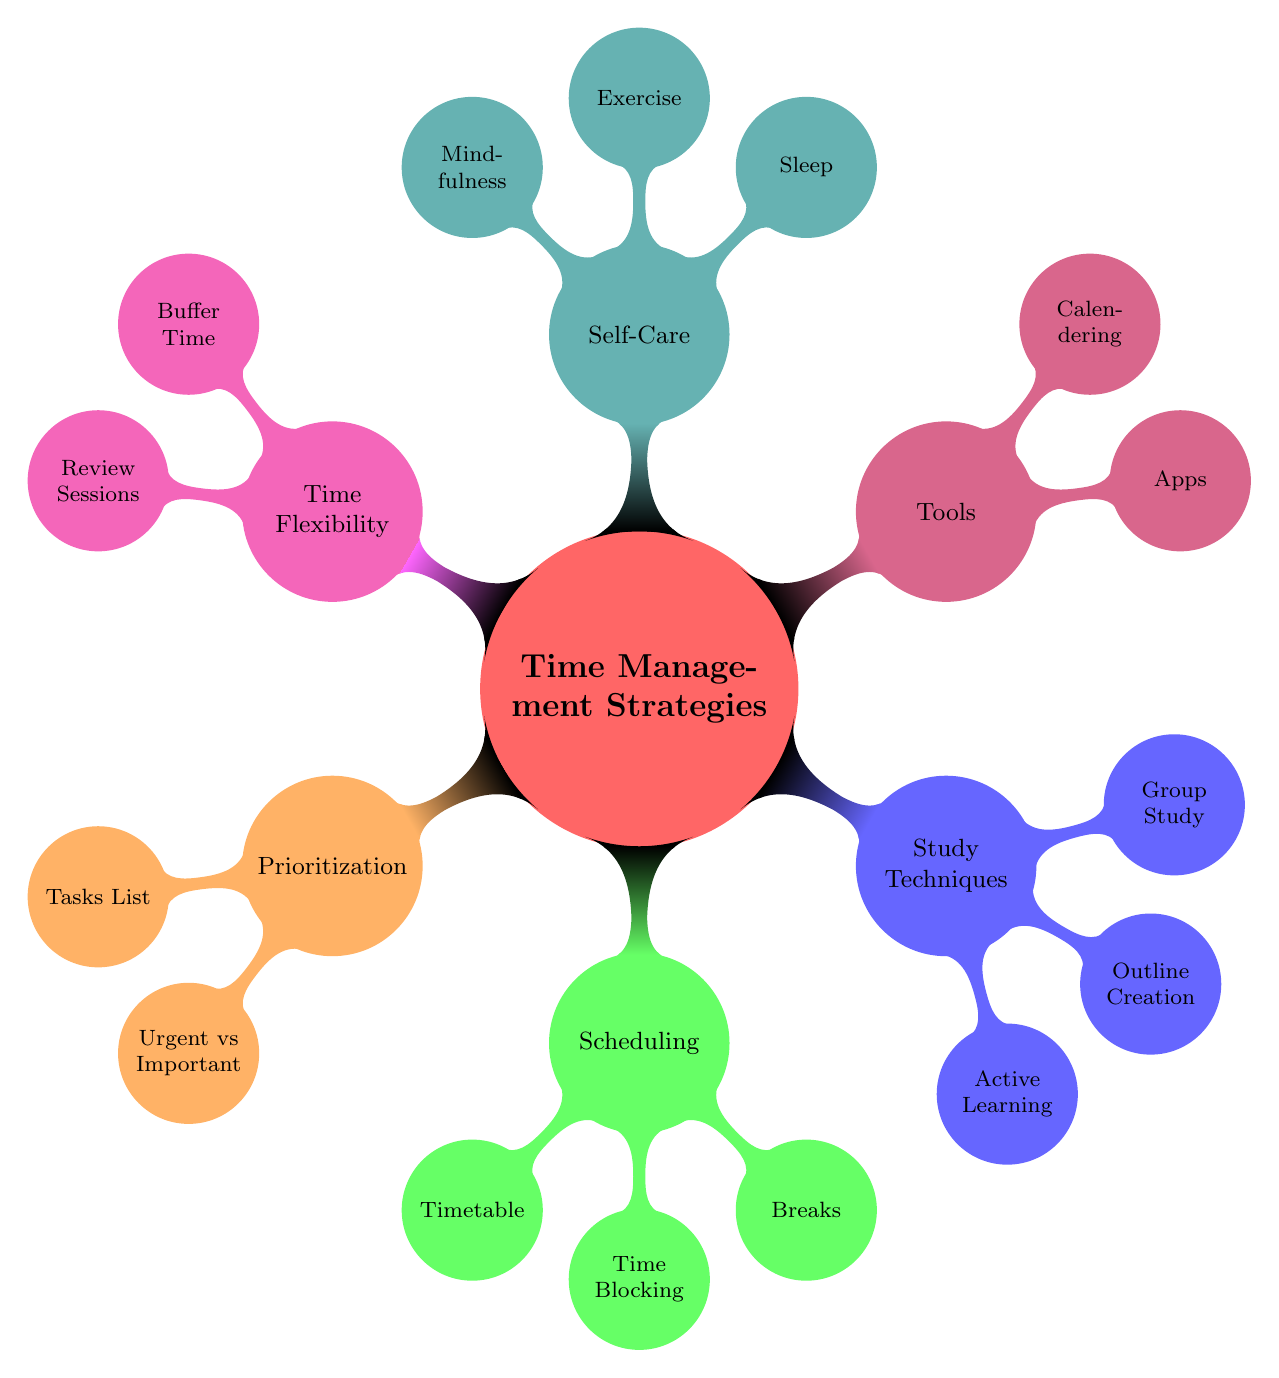What is the main topic of the mind map? The title at the center of the mind map indicates the main topic, which is "Time Management Strategies for Law Students".
Answer: Time Management Strategies for Law Students How many main branches does the diagram have? The main branches are the first level of nodes branching out from the central topic, which are six in total: Prioritization, Scheduling, Study Techniques, Tools, Self-Care, and Time Flexibility.
Answer: 6 What is one strategy listed under the Scheduling branch? By analyzing the nodes under the Scheduling branch, one of the strategies listed is "Timetable".
Answer: Timetable Which technique focuses on physical well-being? In the Self-Care branch, the technique that focuses on physical well-being is "Exercise". The connection to well-being indicates it relates to physical health.
Answer: Exercise Which branch contains a technique related to collaborative learning? Under the Study Techniques branch, the technique related to collaborative learning is "Group Study", which encourages working with peers for effective study sessions.
Answer: Group Study Name a tool mentioned in the Tools branch. The Tools branch lists "Apps" as one of the tools that can assist in time management for law students.
Answer: Apps What is one method for distinguishing tasks in the Prioritization branch? The method mentioned in the Prioritization branch that helps distinguish tasks is the "Eisenhower Matrix", which categorizes tasks based on urgency and importance.
Answer: Eisenhower Matrix How does "Time Blocking" aid in study efficiency? "Time Blocking," found in the Scheduling branch, refers to a strategy that allocates specific segments of time to focus on deep work, thus enhancing study efficiency.
Answer: Time Blocking What is the purpose of Buffer Time according to the diagram? Buffer Time, found in the Time Flexibility branch, serves to allocate time for unforeseen events, which helps accommodate unexpected disruptions in a student’s schedule.
Answer: Buffer Time 